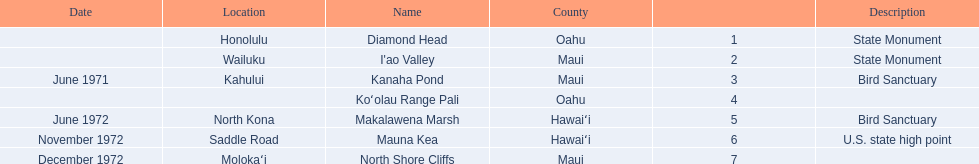Which national natural landmarks in hawaii are in oahu county? Diamond Head, Koʻolau Range Pali. Of these landmarks, which one is listed without a location? Koʻolau Range Pali. 